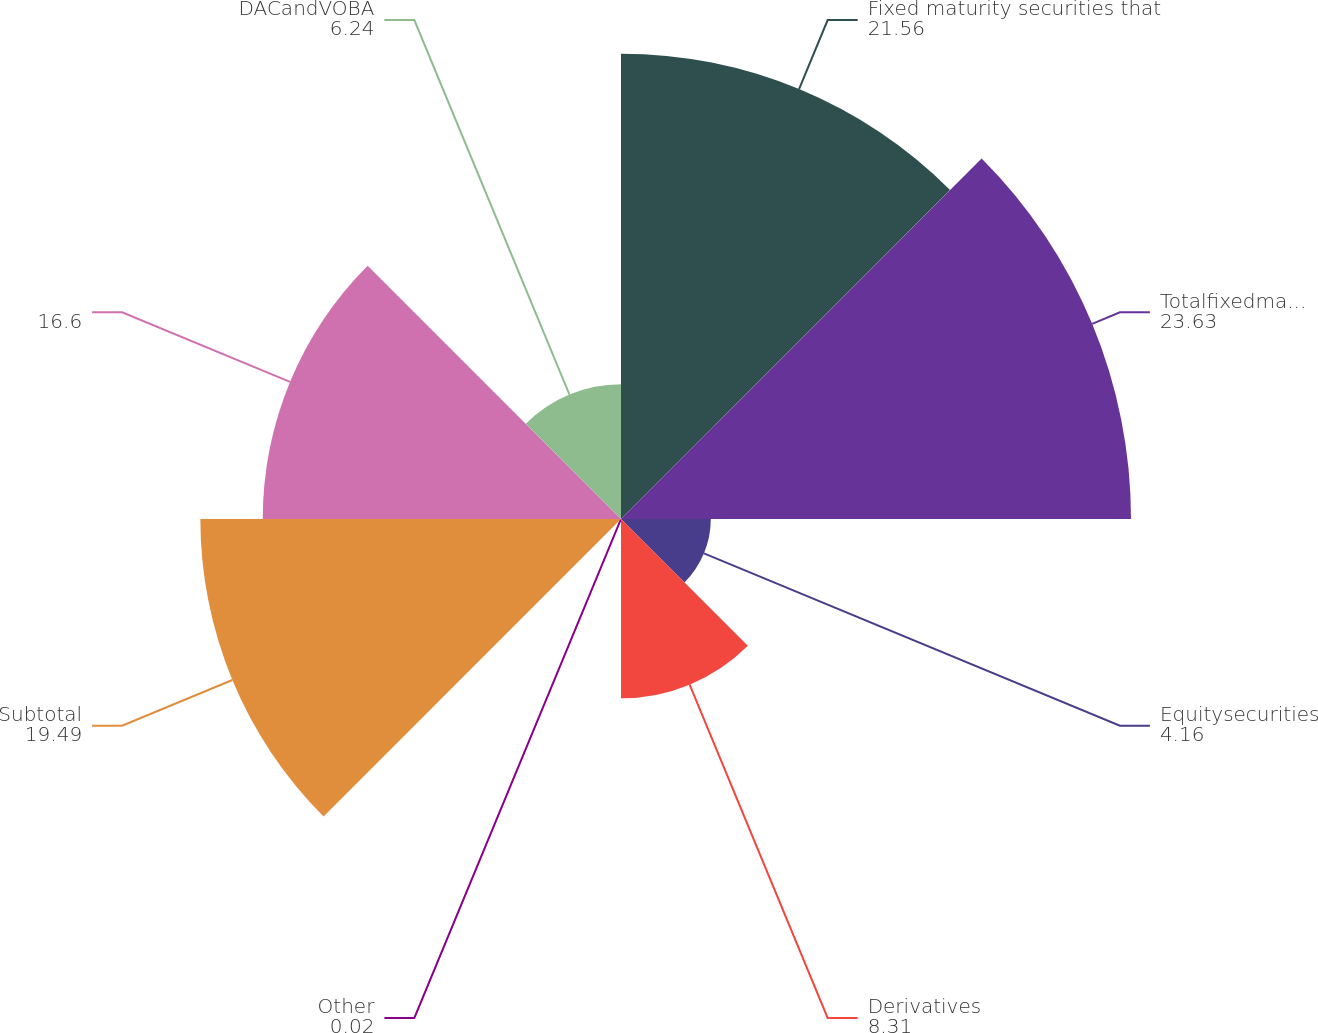<chart> <loc_0><loc_0><loc_500><loc_500><pie_chart><fcel>Fixed maturity securities that<fcel>Totalfixedmaturitysecurities<fcel>Equitysecurities<fcel>Derivatives<fcel>Other<fcel>Subtotal<fcel>Unnamed: 6<fcel>DACandVOBA<nl><fcel>21.56%<fcel>23.63%<fcel>4.16%<fcel>8.31%<fcel>0.02%<fcel>19.49%<fcel>16.6%<fcel>6.24%<nl></chart> 